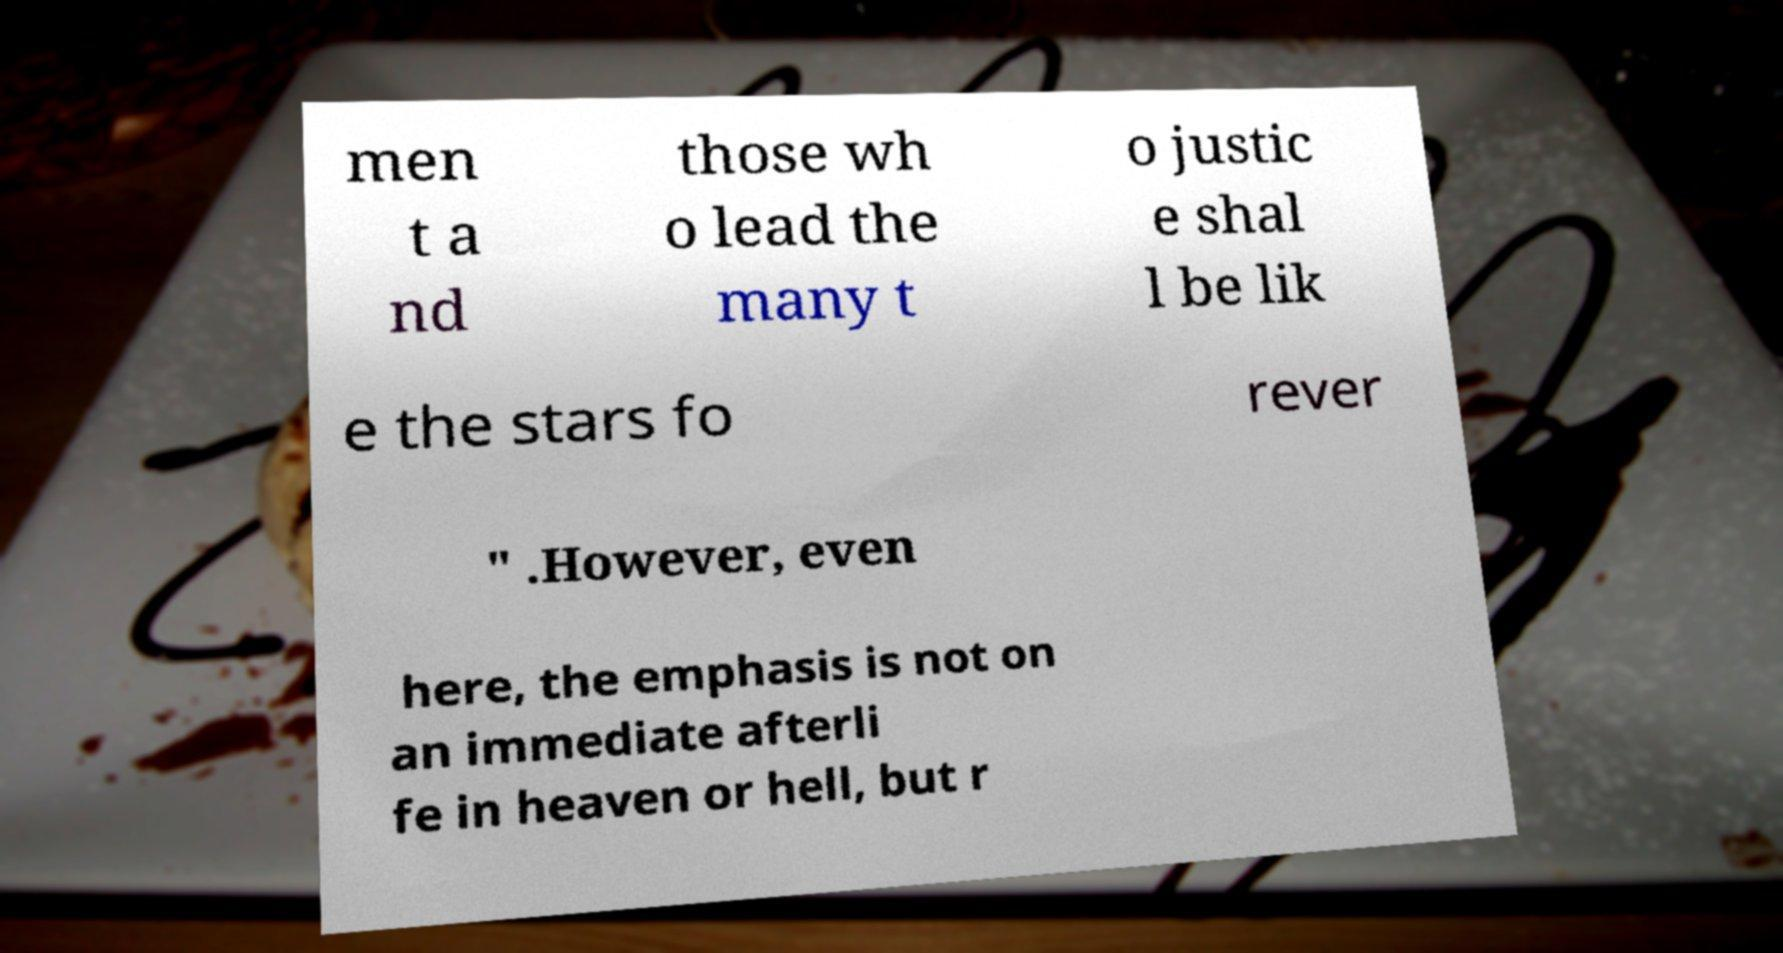Could you assist in decoding the text presented in this image and type it out clearly? men t a nd those wh o lead the many t o justic e shal l be lik e the stars fo rever " .However, even here, the emphasis is not on an immediate afterli fe in heaven or hell, but r 